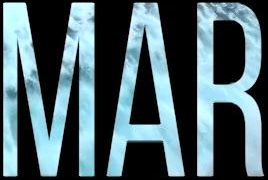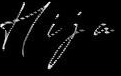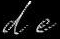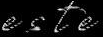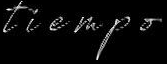What text is displayed in these images sequentially, separated by a semicolon? MAR; Hija; de; este; tiempo 